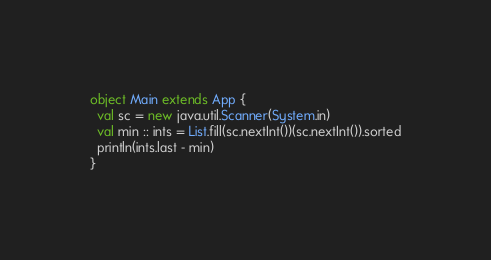<code> <loc_0><loc_0><loc_500><loc_500><_Scala_>object Main extends App {
  val sc = new java.util.Scanner(System.in)
  val min :: ints = List.fill(sc.nextInt())(sc.nextInt()).sorted
  println(ints.last - min)
}
</code> 